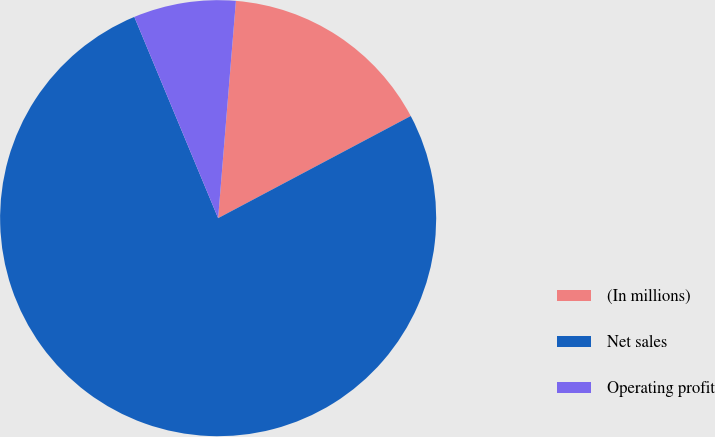Convert chart. <chart><loc_0><loc_0><loc_500><loc_500><pie_chart><fcel>(In millions)<fcel>Net sales<fcel>Operating profit<nl><fcel>15.94%<fcel>76.48%<fcel>7.58%<nl></chart> 